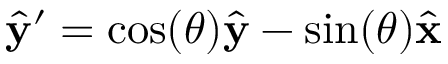Convert formula to latex. <formula><loc_0><loc_0><loc_500><loc_500>\hat { y } ^ { \prime } = \cos ( \theta ) \hat { y } - \sin ( \theta ) \hat { x }</formula> 